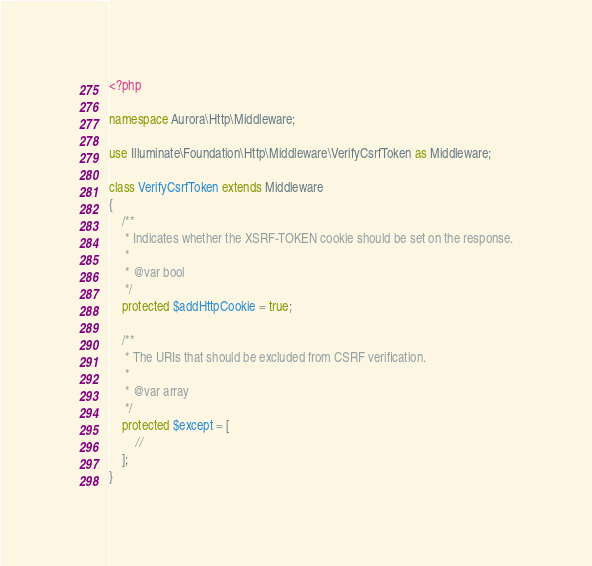Convert code to text. <code><loc_0><loc_0><loc_500><loc_500><_PHP_><?php

namespace Aurora\Http\Middleware;

use Illuminate\Foundation\Http\Middleware\VerifyCsrfToken as Middleware;

class VerifyCsrfToken extends Middleware
{
    /**
     * Indicates whether the XSRF-TOKEN cookie should be set on the response.
     *
     * @var bool
     */
    protected $addHttpCookie = true;

    /**
     * The URIs that should be excluded from CSRF verification.
     *
     * @var array
     */
    protected $except = [
        //
    ];
}
</code> 